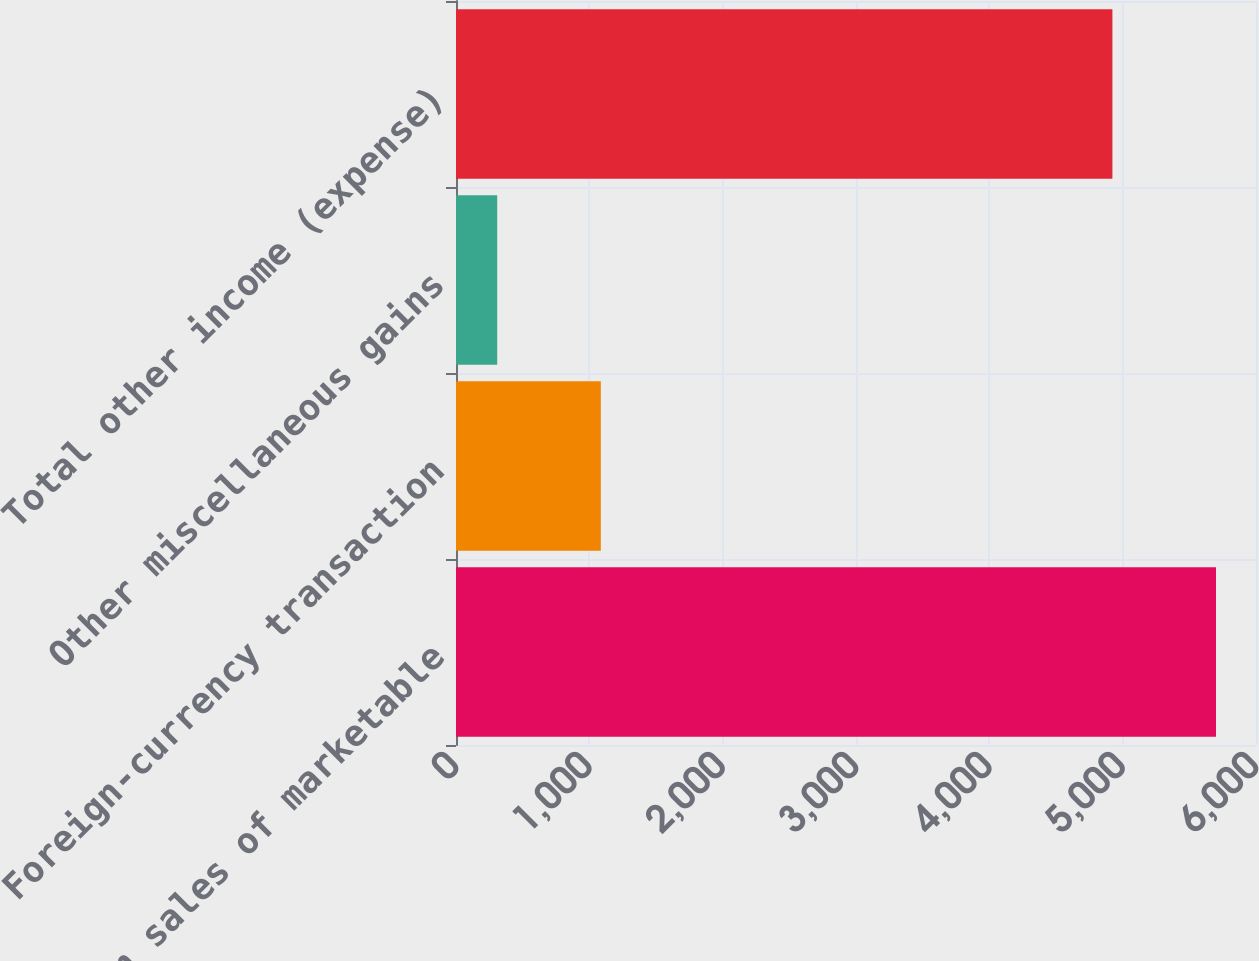Convert chart. <chart><loc_0><loc_0><loc_500><loc_500><bar_chart><fcel>Gains on sales of marketable<fcel>Foreign-currency transaction<fcel>Other miscellaneous gains<fcel>Total other income (expense)<nl><fcel>5700<fcel>1086<fcel>309<fcel>4923<nl></chart> 